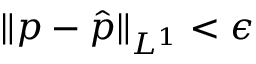Convert formula to latex. <formula><loc_0><loc_0><loc_500><loc_500>\| p - \hat { p } \| _ { L ^ { 1 } } < \epsilon</formula> 